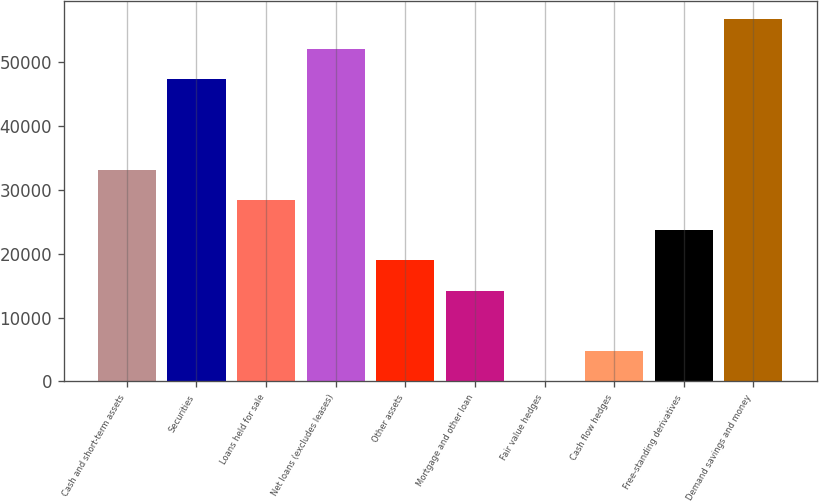<chart> <loc_0><loc_0><loc_500><loc_500><bar_chart><fcel>Cash and short-term assets<fcel>Securities<fcel>Loans held for sale<fcel>Net loans (excludes leases)<fcel>Other assets<fcel>Mortgage and other loan<fcel>Fair value hedges<fcel>Cash flow hedges<fcel>Free-standing derivatives<fcel>Demand savings and money<nl><fcel>33109.2<fcel>47277<fcel>28386.6<fcel>51999.6<fcel>18941.4<fcel>14218.8<fcel>51<fcel>4773.6<fcel>23664<fcel>56722.2<nl></chart> 